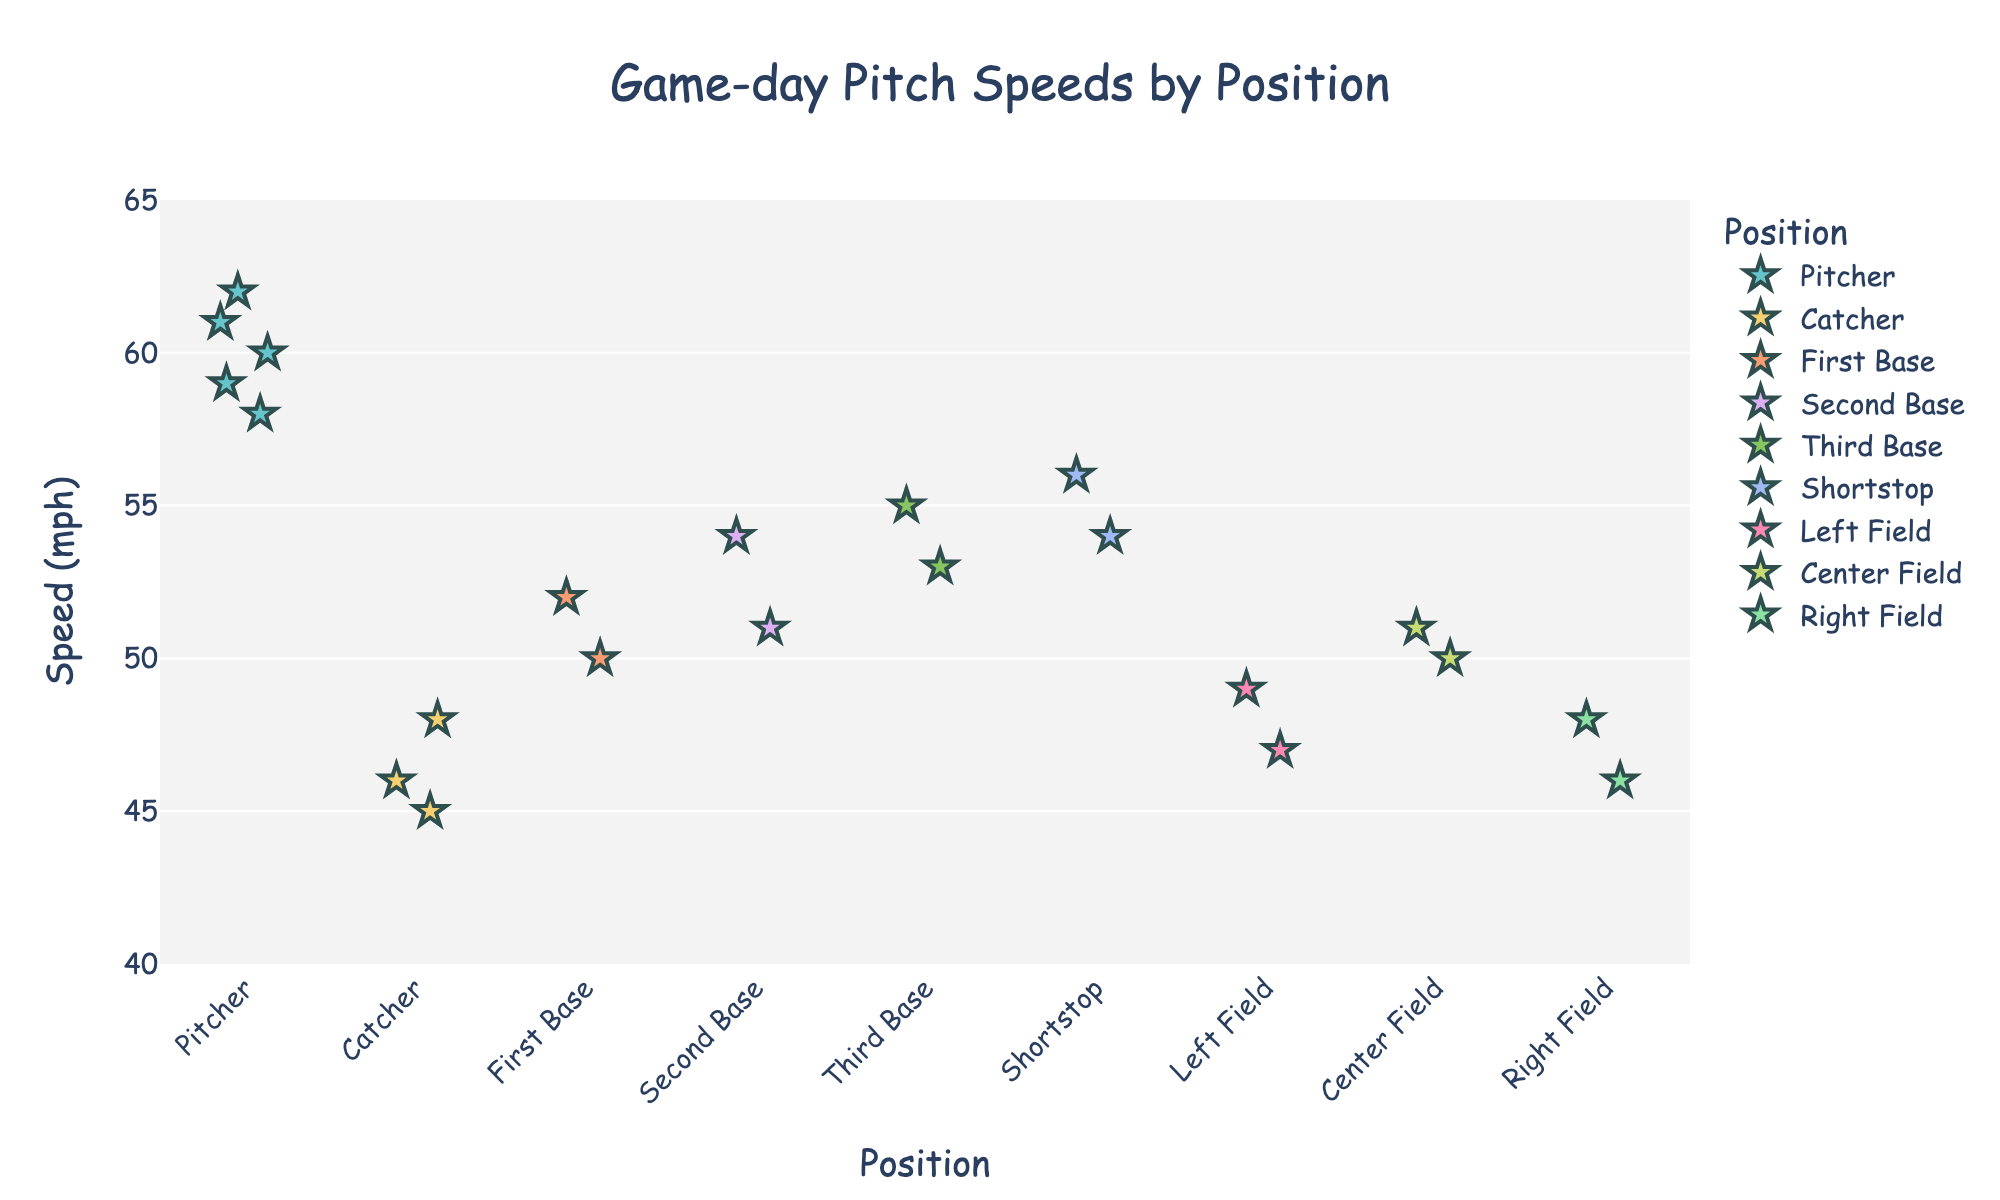Which position has the highest pitch speed? Look at the plot points and identify the one that has the highest value on the y-axis.
Answer: Pitcher What is the range of pitch speeds for the catcher? Look at the plot points for the "Catcher" position and find the minimum and maximum values. The range is the difference between them.
Answer: 45 mph to 48 mph How many total positions are represented in the plot? Count the number of unique position labels along the x-axis.
Answer: 9 Which position has the widest spread in pitch speeds? Compare the range of pitch speeds for each position by looking at the spread in points on the y-axis for each x-axis category.
Answer: Pitcher What is the median pitch speed for the shortstop? Sort the pitch speeds for the "Shortstop" position and find the middle value.
Answer: 55 mph How do the pitch speeds for outfield positions compare with infield positions? Compare the distribution of points for Left Field, Center Field, and Right Field against First Base, Second Base, Third Base, and Shortstop.
Answer: Outfield generally has lower pitch speeds Which infield position has the highest average pitch speed? Calculate the average pitch speed for each infield position (First Base, Second Base, Third Base, Shortstop), and find the highest.
Answer: Shortstop Do any positions have overlapping pitch speeds? If so, which ones? Look for positions whose pitch speed values overlap on the y-axis.
Answer: Yes, many positions overlap, e.g., Second Base and Center Field What is the average pitch speed for the pitchers? Add up all the pitch speeds for the "Pitcher" position and divide by the number of pitches. (60+62+58+61+59)/5 = 60 mph
Answer: 60 mph Which position consistently exhibits lower pitch speeds? Identify the position with the plot points lowest on the y-axis and smallest spread.
Answer: Catcher 